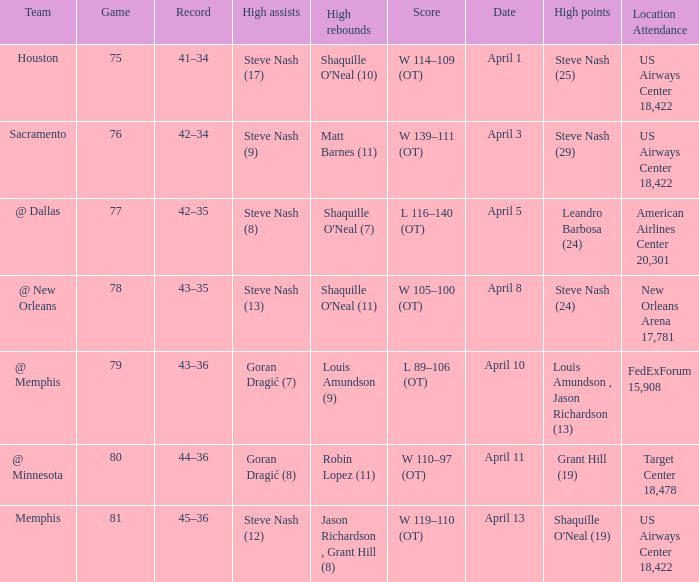Steve Nash (24) got high points for how many teams? 1.0. 